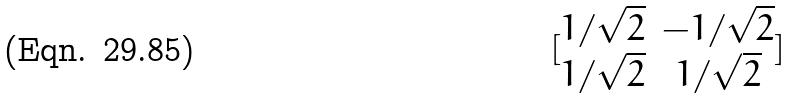<formula> <loc_0><loc_0><loc_500><loc_500>[ \begin{matrix} 1 / \sqrt { 2 } & - 1 / \sqrt { 2 } \\ 1 / \sqrt { 2 } & 1 / \sqrt { 2 } \end{matrix} ]</formula> 